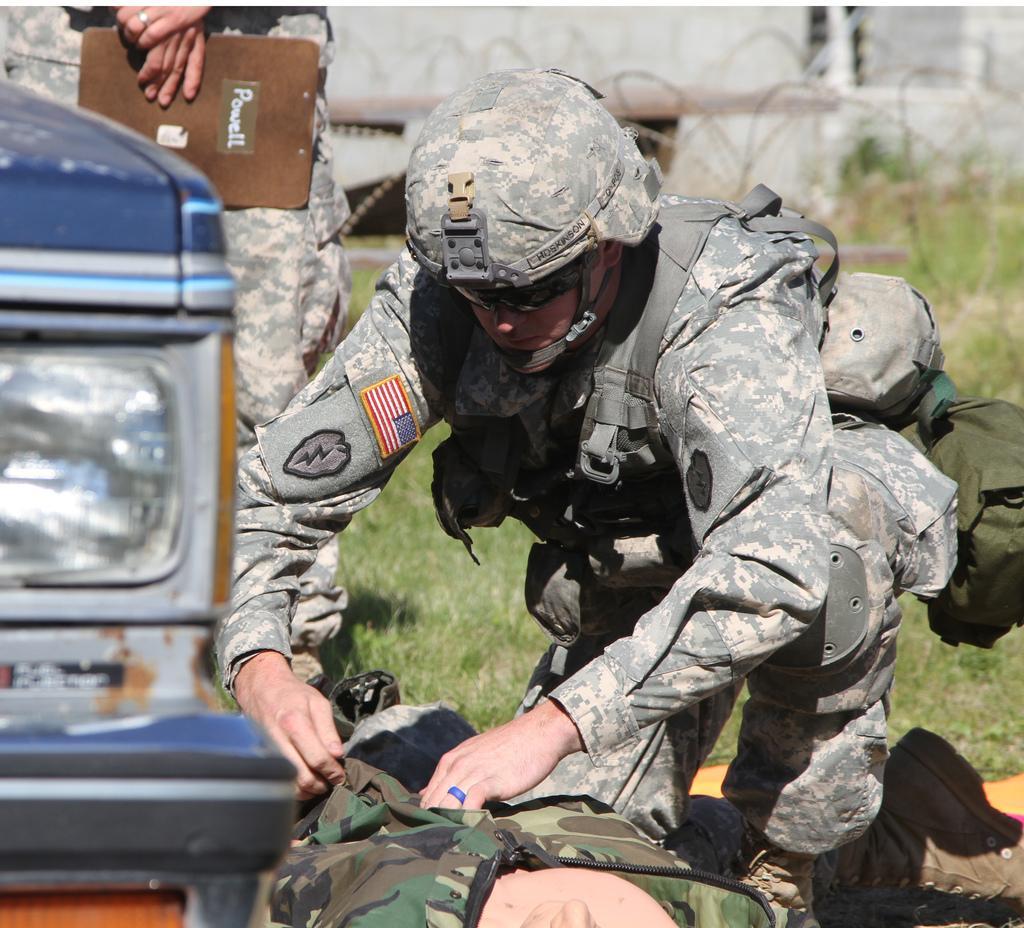How would you summarize this image in a sentence or two? In this image we can see three persons, among them one person is sitting in squat position and the other person is lying on the ground, also we can see another person truncated and holding an object, in the background we can see a building and the grass. 